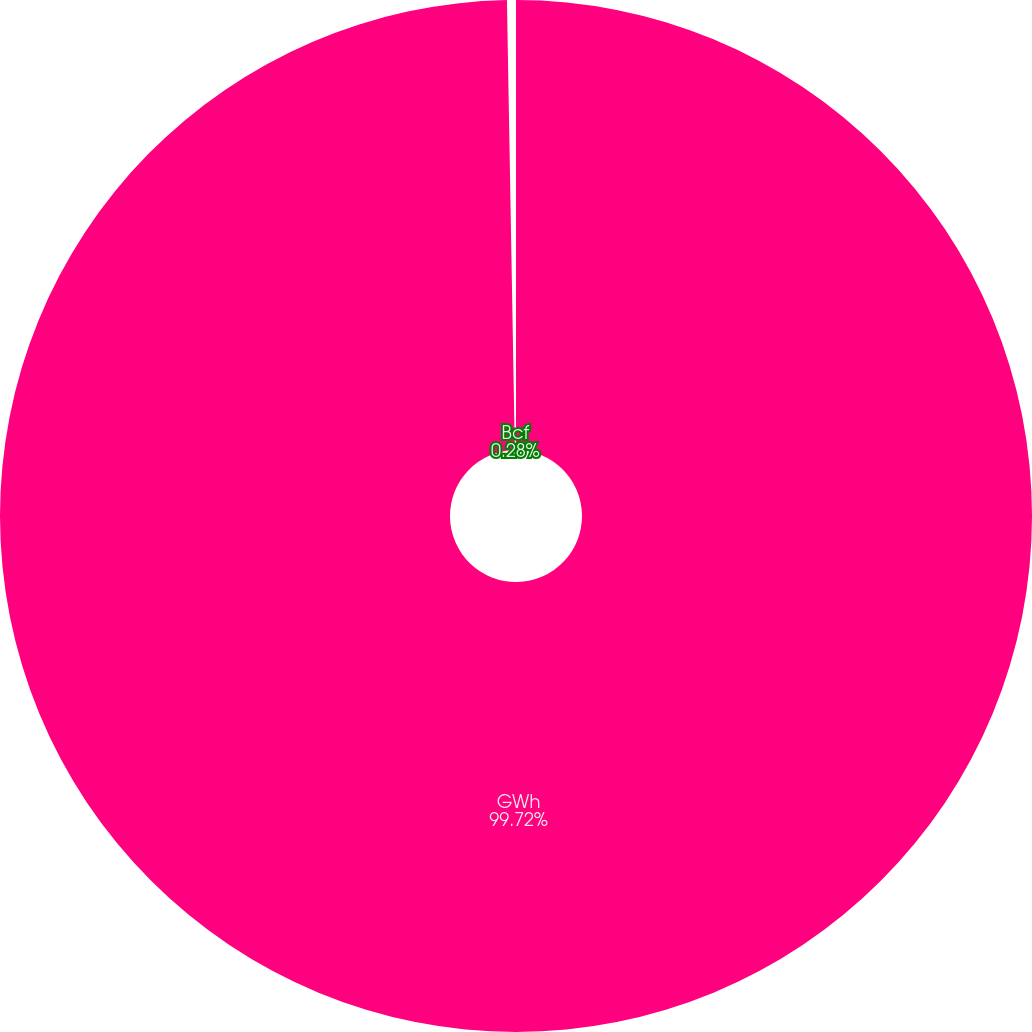<chart> <loc_0><loc_0><loc_500><loc_500><pie_chart><fcel>GWh<fcel>Bcf<nl><fcel>99.72%<fcel>0.28%<nl></chart> 